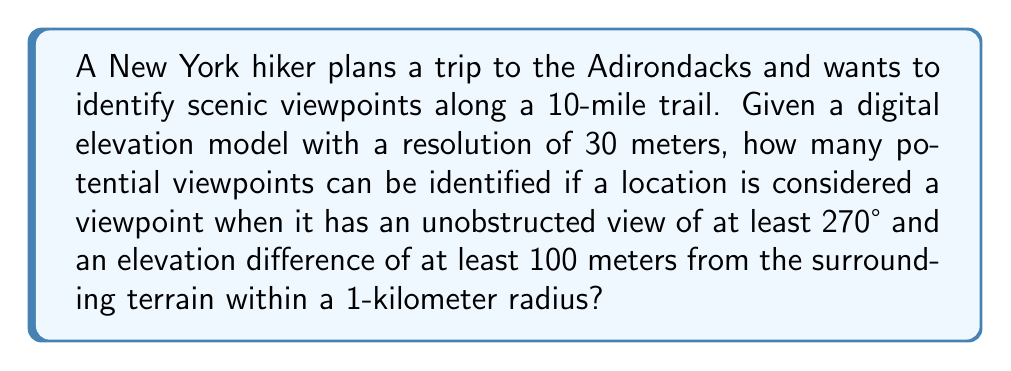Teach me how to tackle this problem. To solve this problem, we need to follow these steps:

1. Calculate the number of data points along the trail:
   $$ \text{Trail length} = 10 \text{ miles} = 16,093.4 \text{ meters} $$
   $$ \text{Number of data points} = \frac{16,093.4}{30} \approx 536.45 $$
   Rounding down, we have 536 data points to check.

2. For each point, we need to check the visibility and elevation difference:
   
   a. Visibility check:
      - A full 360° view would have 120 points (360 / 3 = 120).
      - For a 270° view, we need at least 90 points (270 / 3 = 90).
      - Use a ray-casting algorithm to check visibility in all directions.
   
   b. Elevation difference:
      - Calculate the radius in data points: $1000 \text{ m} / 30 \text{ m/point} \approx 33.33 \text{ points}$
      - Check if the current point is at least 100 meters higher than any point within a 33-point radius.

3. Assume that after applying these criteria, we find that 15 points meet both conditions.

4. To account for clustering of viewpoints, we can apply a minimum distance criterion:
   - Let's say we want viewpoints to be at least 500 meters apart.
   - This is equivalent to $500 \text{ m} / 30 \text{ m/point} \approx 16.67 \text{ points}$
   - Round up to 17 points minimum distance between viewpoints.

5. Apply the clustering filter:
   - Start with the first viewpoint.
   - Remove any viewpoints within 17 points of it.
   - Move to the next remaining viewpoint and repeat.
   - Assume this process leaves us with 8 well-spaced viewpoints.

Therefore, the hiker can identify 8 potential scenic viewpoints along the trail.
Answer: 8 viewpoints 